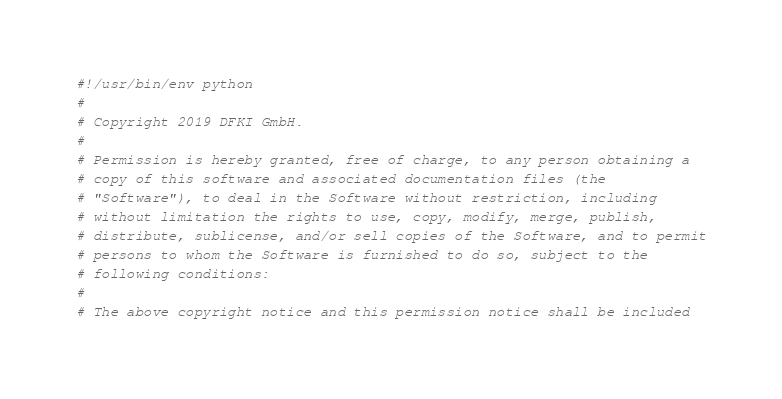Convert code to text. <code><loc_0><loc_0><loc_500><loc_500><_Python_>#!/usr/bin/env python
#
# Copyright 2019 DFKI GmbH.
#
# Permission is hereby granted, free of charge, to any person obtaining a
# copy of this software and associated documentation files (the
# "Software"), to deal in the Software without restriction, including
# without limitation the rights to use, copy, modify, merge, publish,
# distribute, sublicense, and/or sell copies of the Software, and to permit
# persons to whom the Software is furnished to do so, subject to the
# following conditions:
#
# The above copyright notice and this permission notice shall be included</code> 